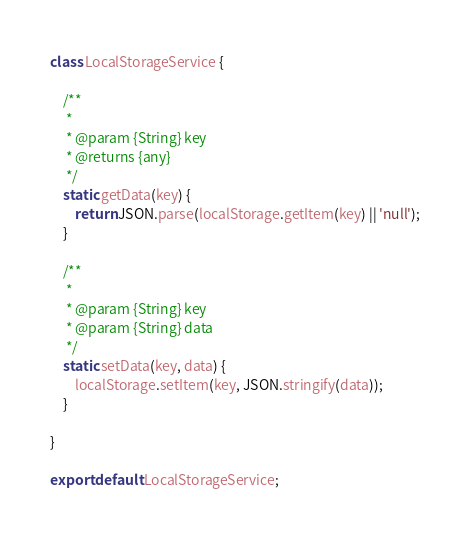<code> <loc_0><loc_0><loc_500><loc_500><_JavaScript_>class LocalStorageService {

	/**
	 *
	 * @param {String} key
	 * @returns {any}
	 */
	static getData(key) {
		return JSON.parse(localStorage.getItem(key) || 'null');
	}

	/**
	 *
	 * @param {String} key
	 * @param {String} data
	 */
	static setData(key, data) {
		localStorage.setItem(key, JSON.stringify(data));
	}

}

export default LocalStorageService;

</code> 